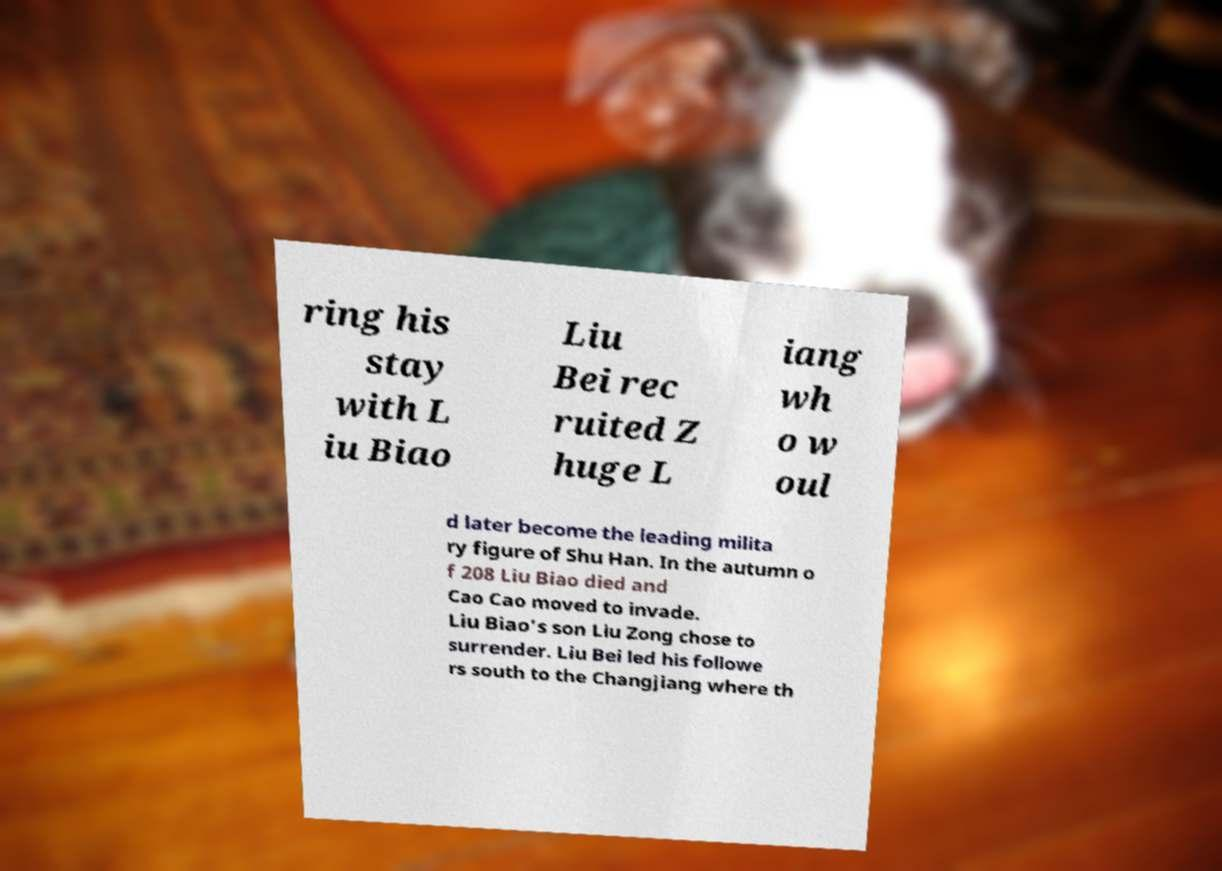Could you extract and type out the text from this image? ring his stay with L iu Biao Liu Bei rec ruited Z huge L iang wh o w oul d later become the leading milita ry figure of Shu Han. In the autumn o f 208 Liu Biao died and Cao Cao moved to invade. Liu Biao's son Liu Zong chose to surrender. Liu Bei led his followe rs south to the Changjiang where th 